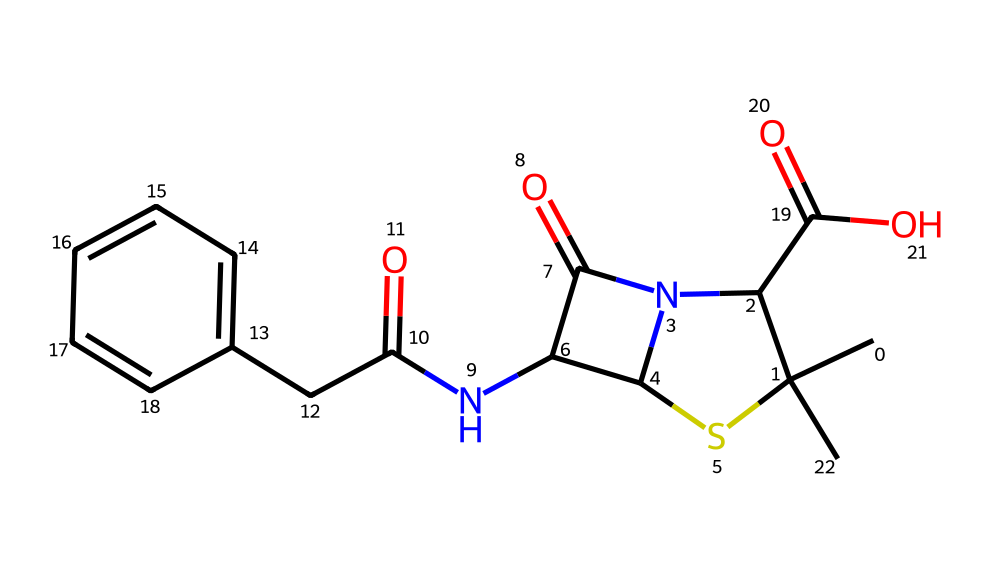What is the molecular formula of the compound represented by this SMILES? To derive the molecular formula, we need to count the types and numbers of atoms present in the structure. Analyzing the provided SMILES, we identify 12 carbon (C) atoms, 16 hydrogen (H) atoms, 4 nitrogen (N) atoms, 3 oxygen (O) atoms, and 1 sulfur (S) atom. Therefore, the molecular formula is C12H16N4O3S.
Answer: C12H16N4O3S How many nitrogen atoms are present? By examining the SMILES structure, we can see that there are 4 nitrogen (N) atoms indicated in the formula.
Answer: 4 What functional groups can be identified in this compound? The SMILES indicates the presence of carboxylic acid (–COOH), amine (–NH2), and a thioamide group (–C(S)–) as functional groups based on the structure shown in the representation.
Answer: carboxylic acid, amine, thioamide What is the significance of the sulfur atom in antibiotic compounds? The presence of sulfur in antibiotic compounds is often related to their mechanism of action or biological activity, as sulfur-containing groups can influence the binding affinity of the antibiotic to its target, affecting efficacy.
Answer: binding affinity What is the type of this antibiotic compound based on its structure? Considering the structural features including the multiple nitrogen atoms and the cyclic nature present in the SMILES, this compound can be classified as a beta-lactam antibiotic, which is known for its broad spectrum of activity.
Answer: beta-lactam antibiotic How many rings are present in this structure? Observing the SMILES representation, there is one cyclic structure (ring) present in the molecule that is crucial for its biological function and stability.
Answer: 1 